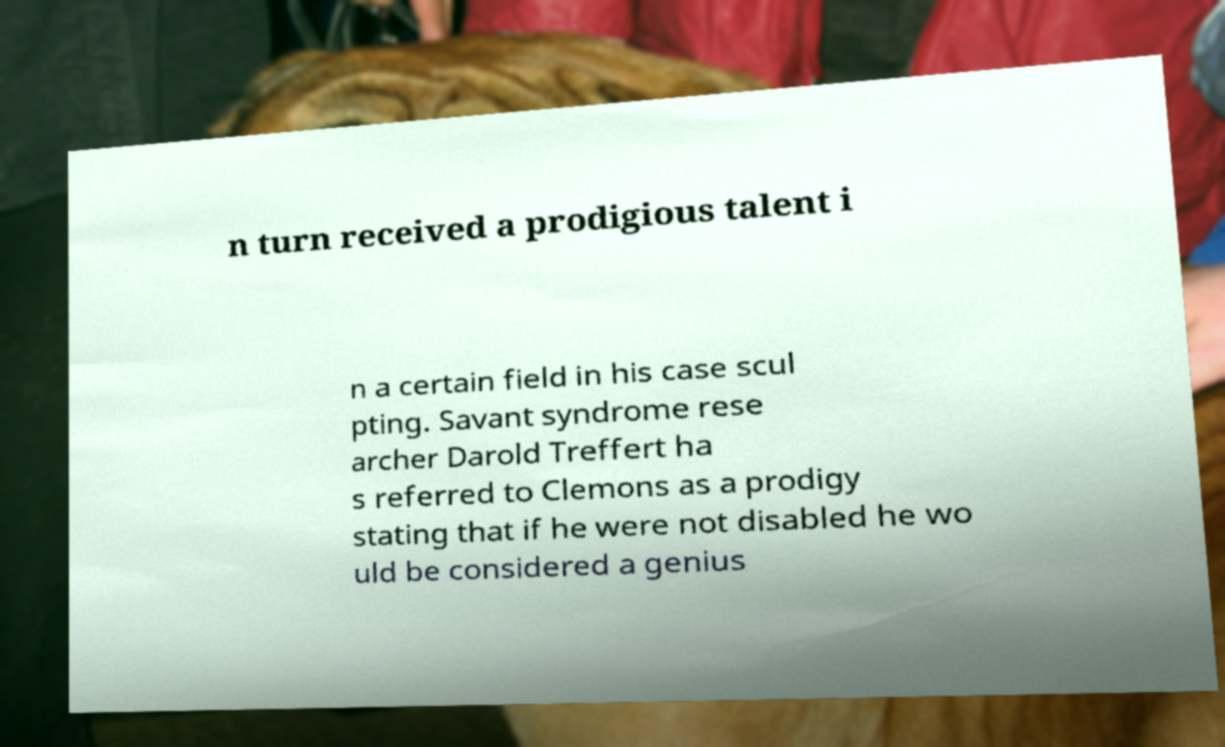Can you accurately transcribe the text from the provided image for me? n turn received a prodigious talent i n a certain field in his case scul pting. Savant syndrome rese archer Darold Treffert ha s referred to Clemons as a prodigy stating that if he were not disabled he wo uld be considered a genius 